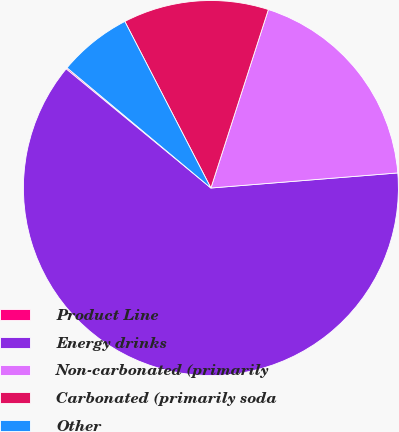Convert chart. <chart><loc_0><loc_0><loc_500><loc_500><pie_chart><fcel>Product Line<fcel>Energy drinks<fcel>Non-carbonated (primarily<fcel>Carbonated (primarily soda<fcel>Other<nl><fcel>0.12%<fcel>62.24%<fcel>18.76%<fcel>12.55%<fcel>6.33%<nl></chart> 